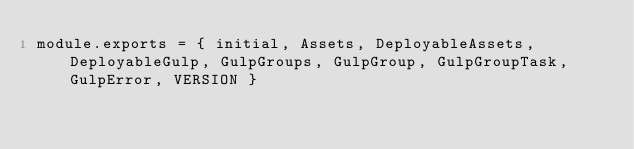<code> <loc_0><loc_0><loc_500><loc_500><_JavaScript_>module.exports = { initial, Assets, DeployableAssets, DeployableGulp, GulpGroups, GulpGroup, GulpGroupTask, GulpError, VERSION }

</code> 